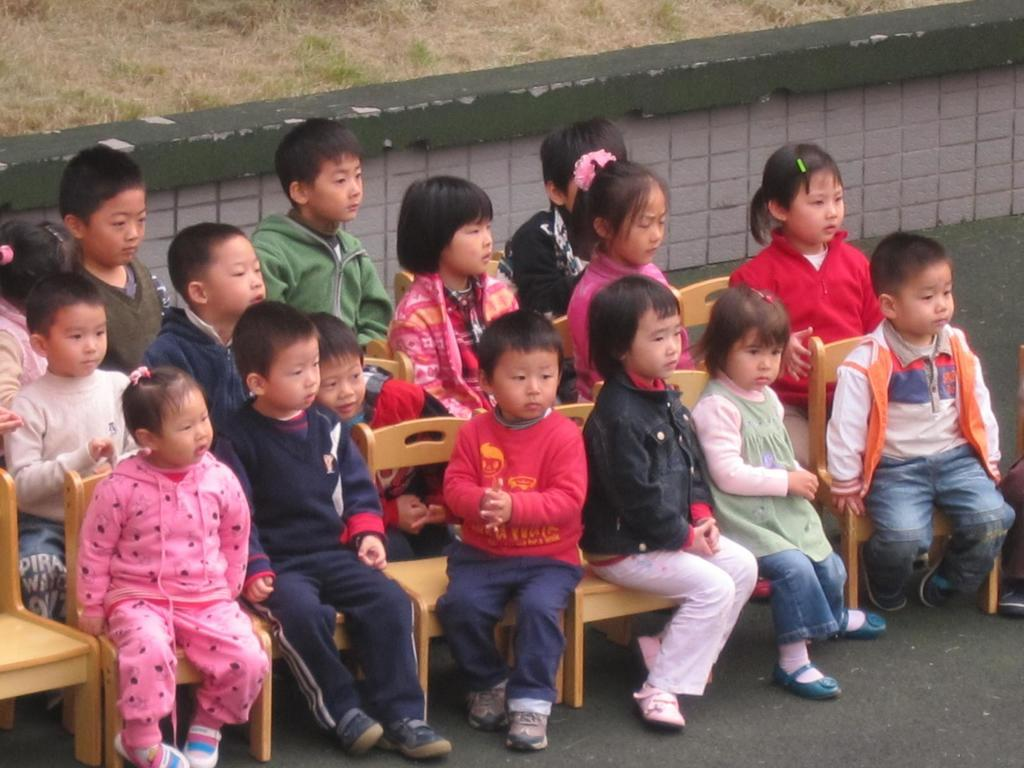What are the children doing in the image? The children are sitting on chairs in the image. What is located behind the children? There is a wall behind the children. What type of vegetation can be seen behind the wall? There is grass visible behind the wall. What type of toy is being flown by the children in the image? There is no toy being flown by the children in the image; they are sitting on chairs. 